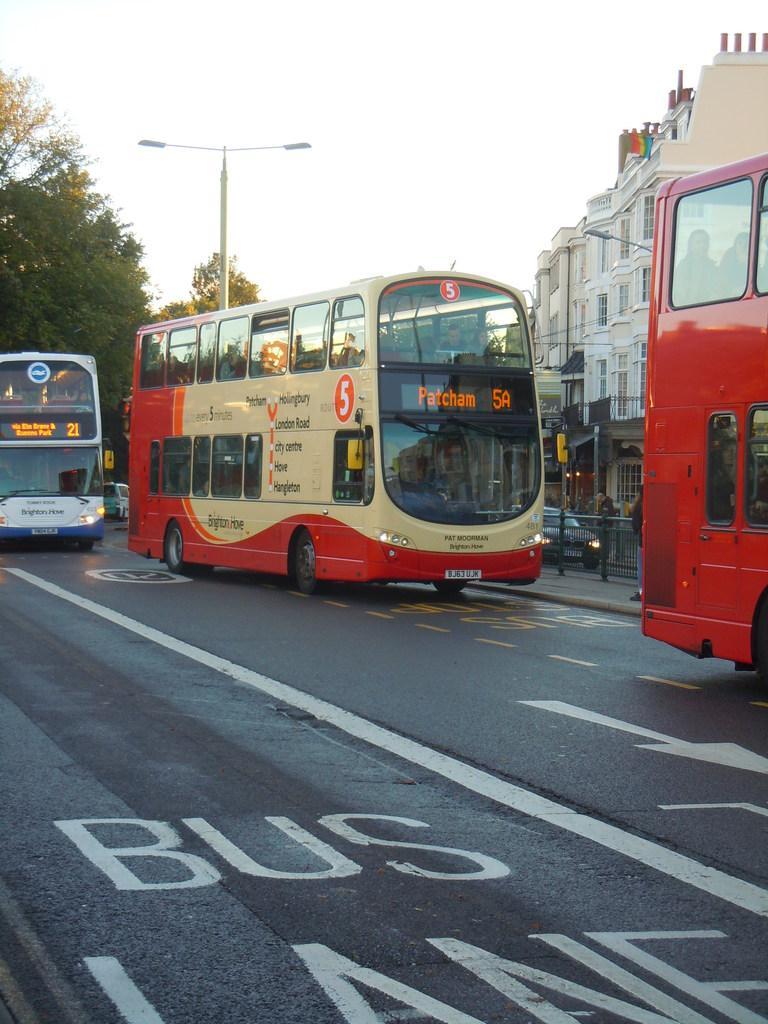Can you describe this image briefly? In this image, we can see vehicles on the road. There is a building on the right side of the image. There are some trees on the left side of the image. There is a street pole in the middle of the image. At the top of the image, we can see the sky. 